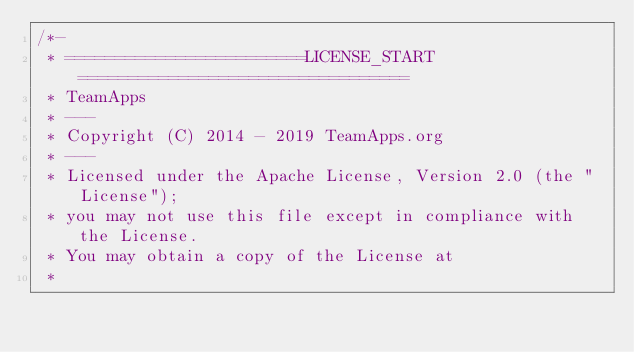Convert code to text. <code><loc_0><loc_0><loc_500><loc_500><_Java_>/*-
 * ========================LICENSE_START=================================
 * TeamApps
 * ---
 * Copyright (C) 2014 - 2019 TeamApps.org
 * ---
 * Licensed under the Apache License, Version 2.0 (the "License");
 * you may not use this file except in compliance with the License.
 * You may obtain a copy of the License at
 * </code> 